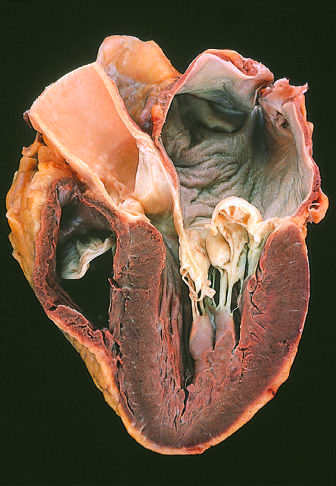what is prominent hooding with?
Answer the question using a single word or phrase. Prolapse of the posterior mitral leaflet into the left atrium 